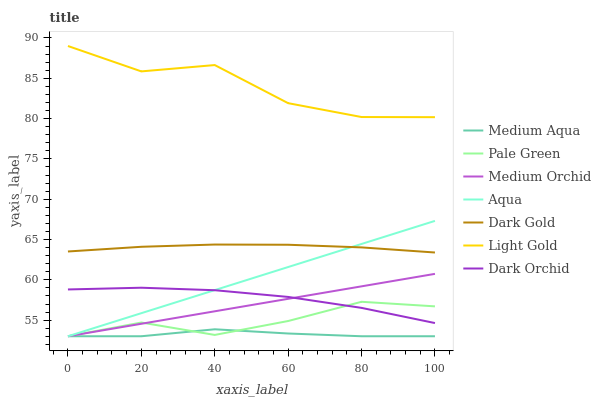Does Medium Orchid have the minimum area under the curve?
Answer yes or no. No. Does Medium Orchid have the maximum area under the curve?
Answer yes or no. No. Is Aqua the smoothest?
Answer yes or no. No. Is Aqua the roughest?
Answer yes or no. No. Does Dark Orchid have the lowest value?
Answer yes or no. No. Does Medium Orchid have the highest value?
Answer yes or no. No. Is Aqua less than Light Gold?
Answer yes or no. Yes. Is Dark Gold greater than Medium Aqua?
Answer yes or no. Yes. Does Aqua intersect Light Gold?
Answer yes or no. No. 